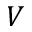Convert formula to latex. <formula><loc_0><loc_0><loc_500><loc_500>V</formula> 